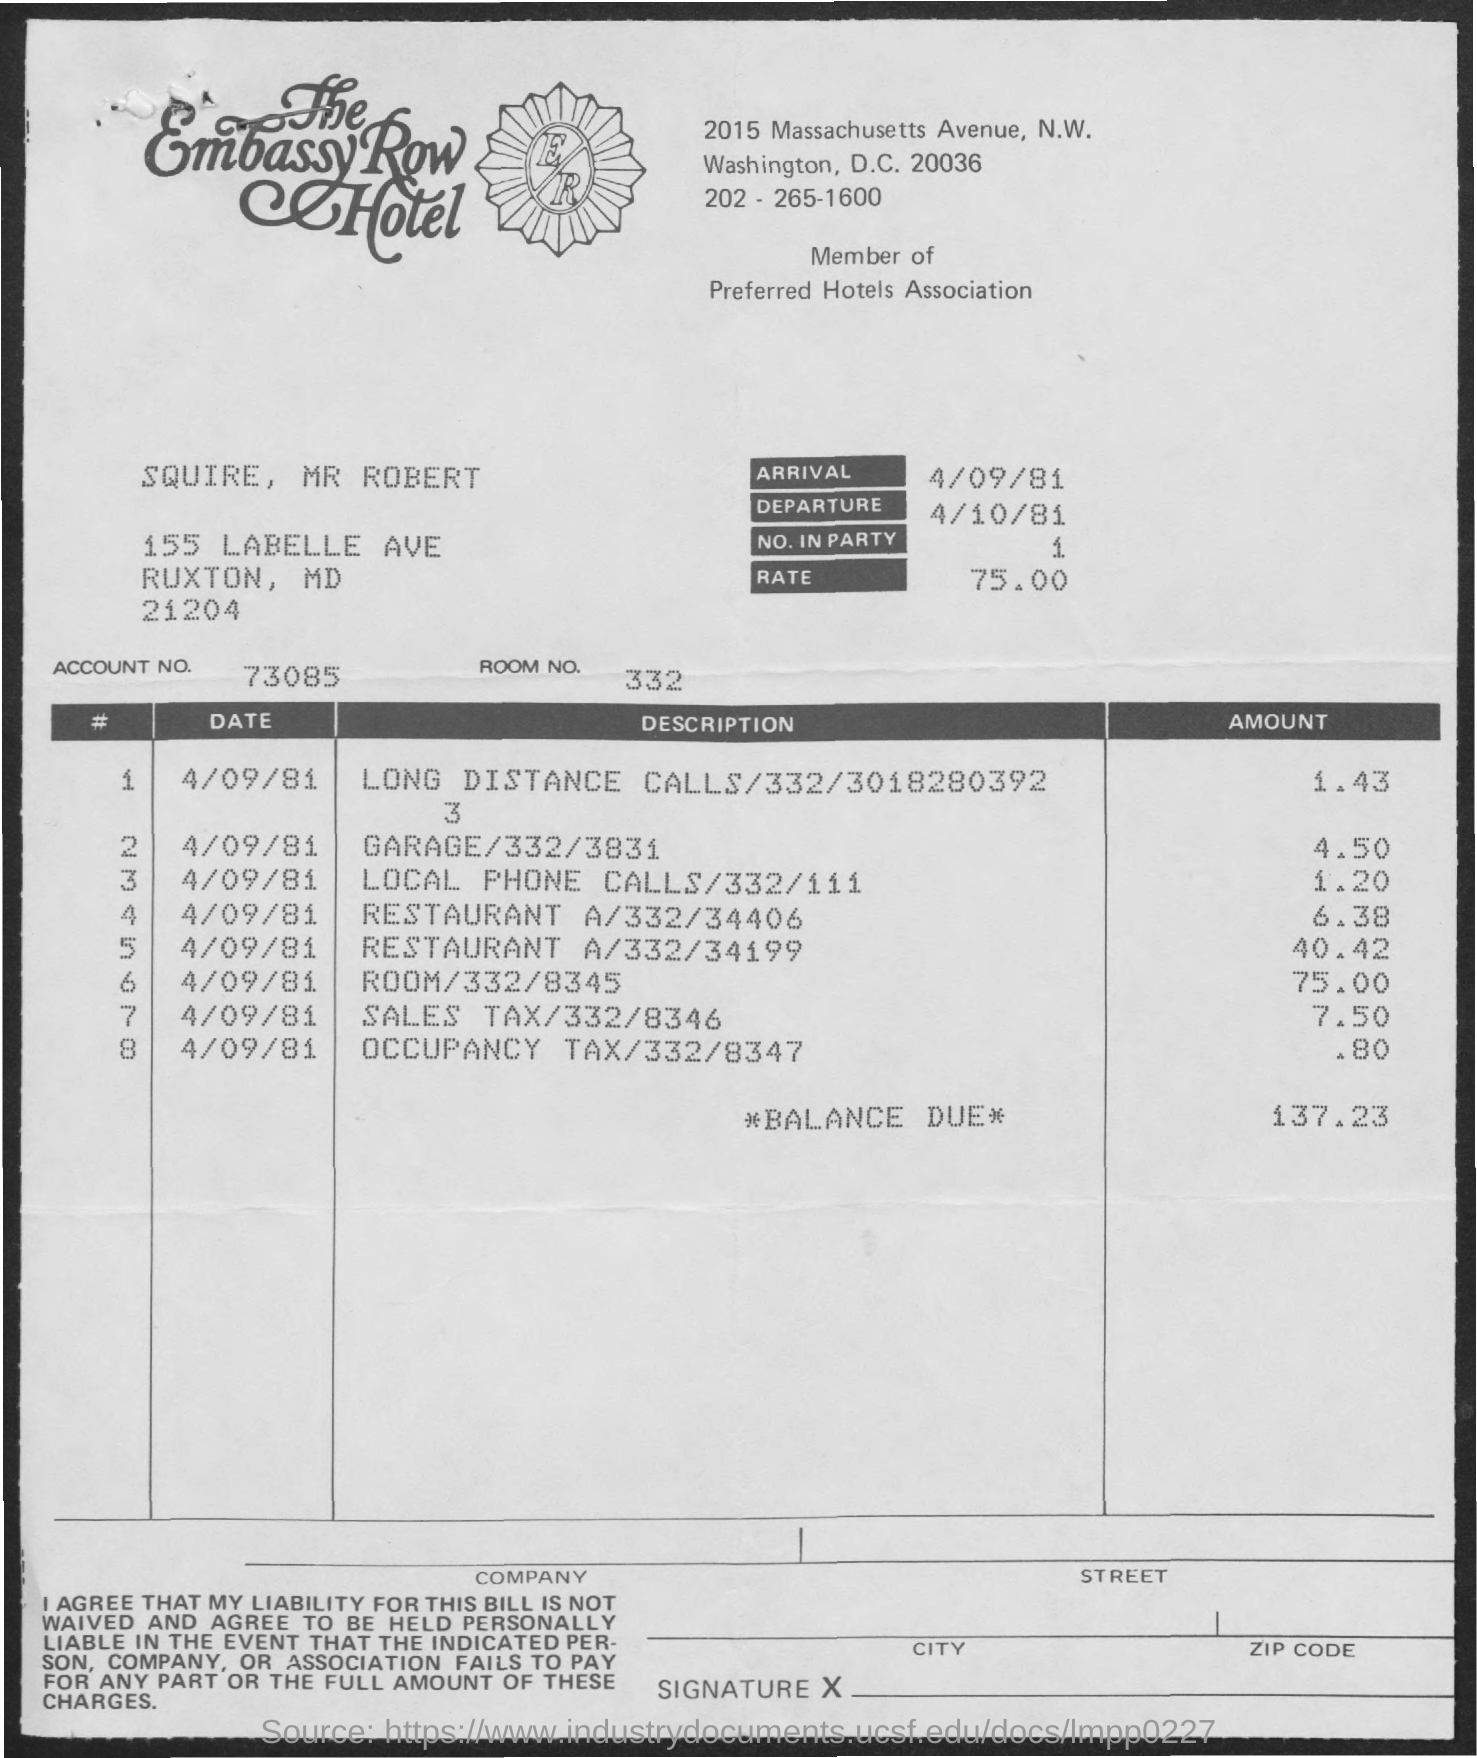What is the arrival date mentioned ?
Offer a terse response. 4/09/81. What is the departure date  mentioned ?
Ensure brevity in your answer.  4/10/81. What is the no. in party mentioned ?
Give a very brief answer. 1. What is the rate mentioned ?
Your response must be concise. 75.00. What is the account no. mentioned ?
Keep it short and to the point. 73085. What is the room no. mentioned ?
Provide a succinct answer. 332. What is the amount of balance due mentioned ?
Provide a short and direct response. 137.23. What is the amount for garage mentioned ?
Offer a terse response. 4.50. What is the amount for sales tax mentioned ?
Keep it short and to the point. 7.50. What is the amount for occupancy tax mentioned ?
Your response must be concise. .80. 